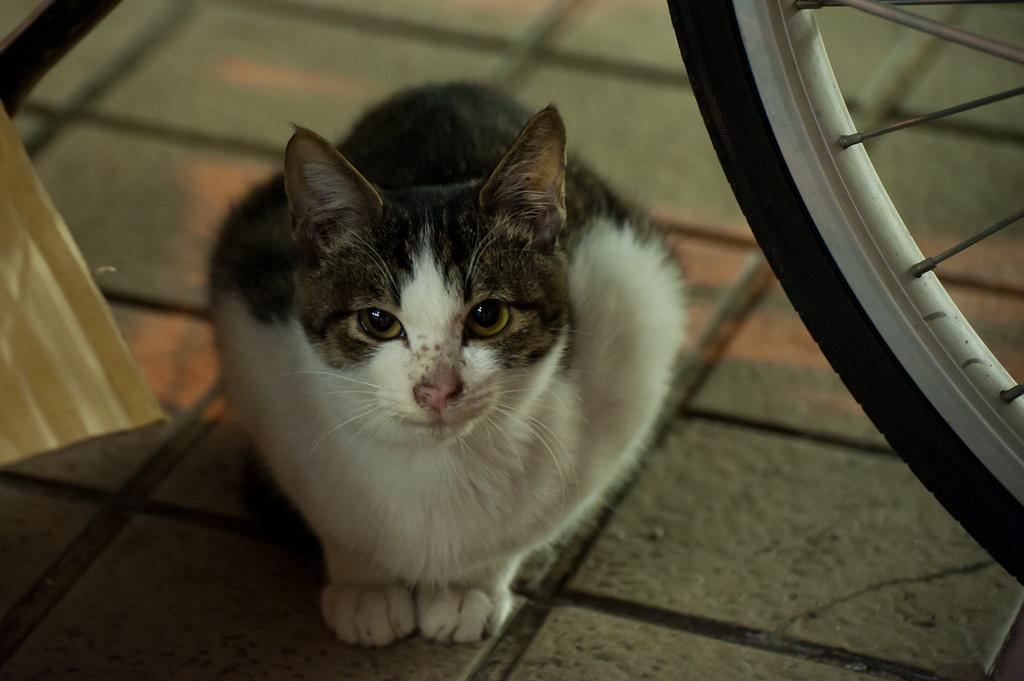Describe this image in one or two sentences. There is a cat on the floor as we can see in the middle of this image and there is a wheel of a bicycle on the right side of this image. 